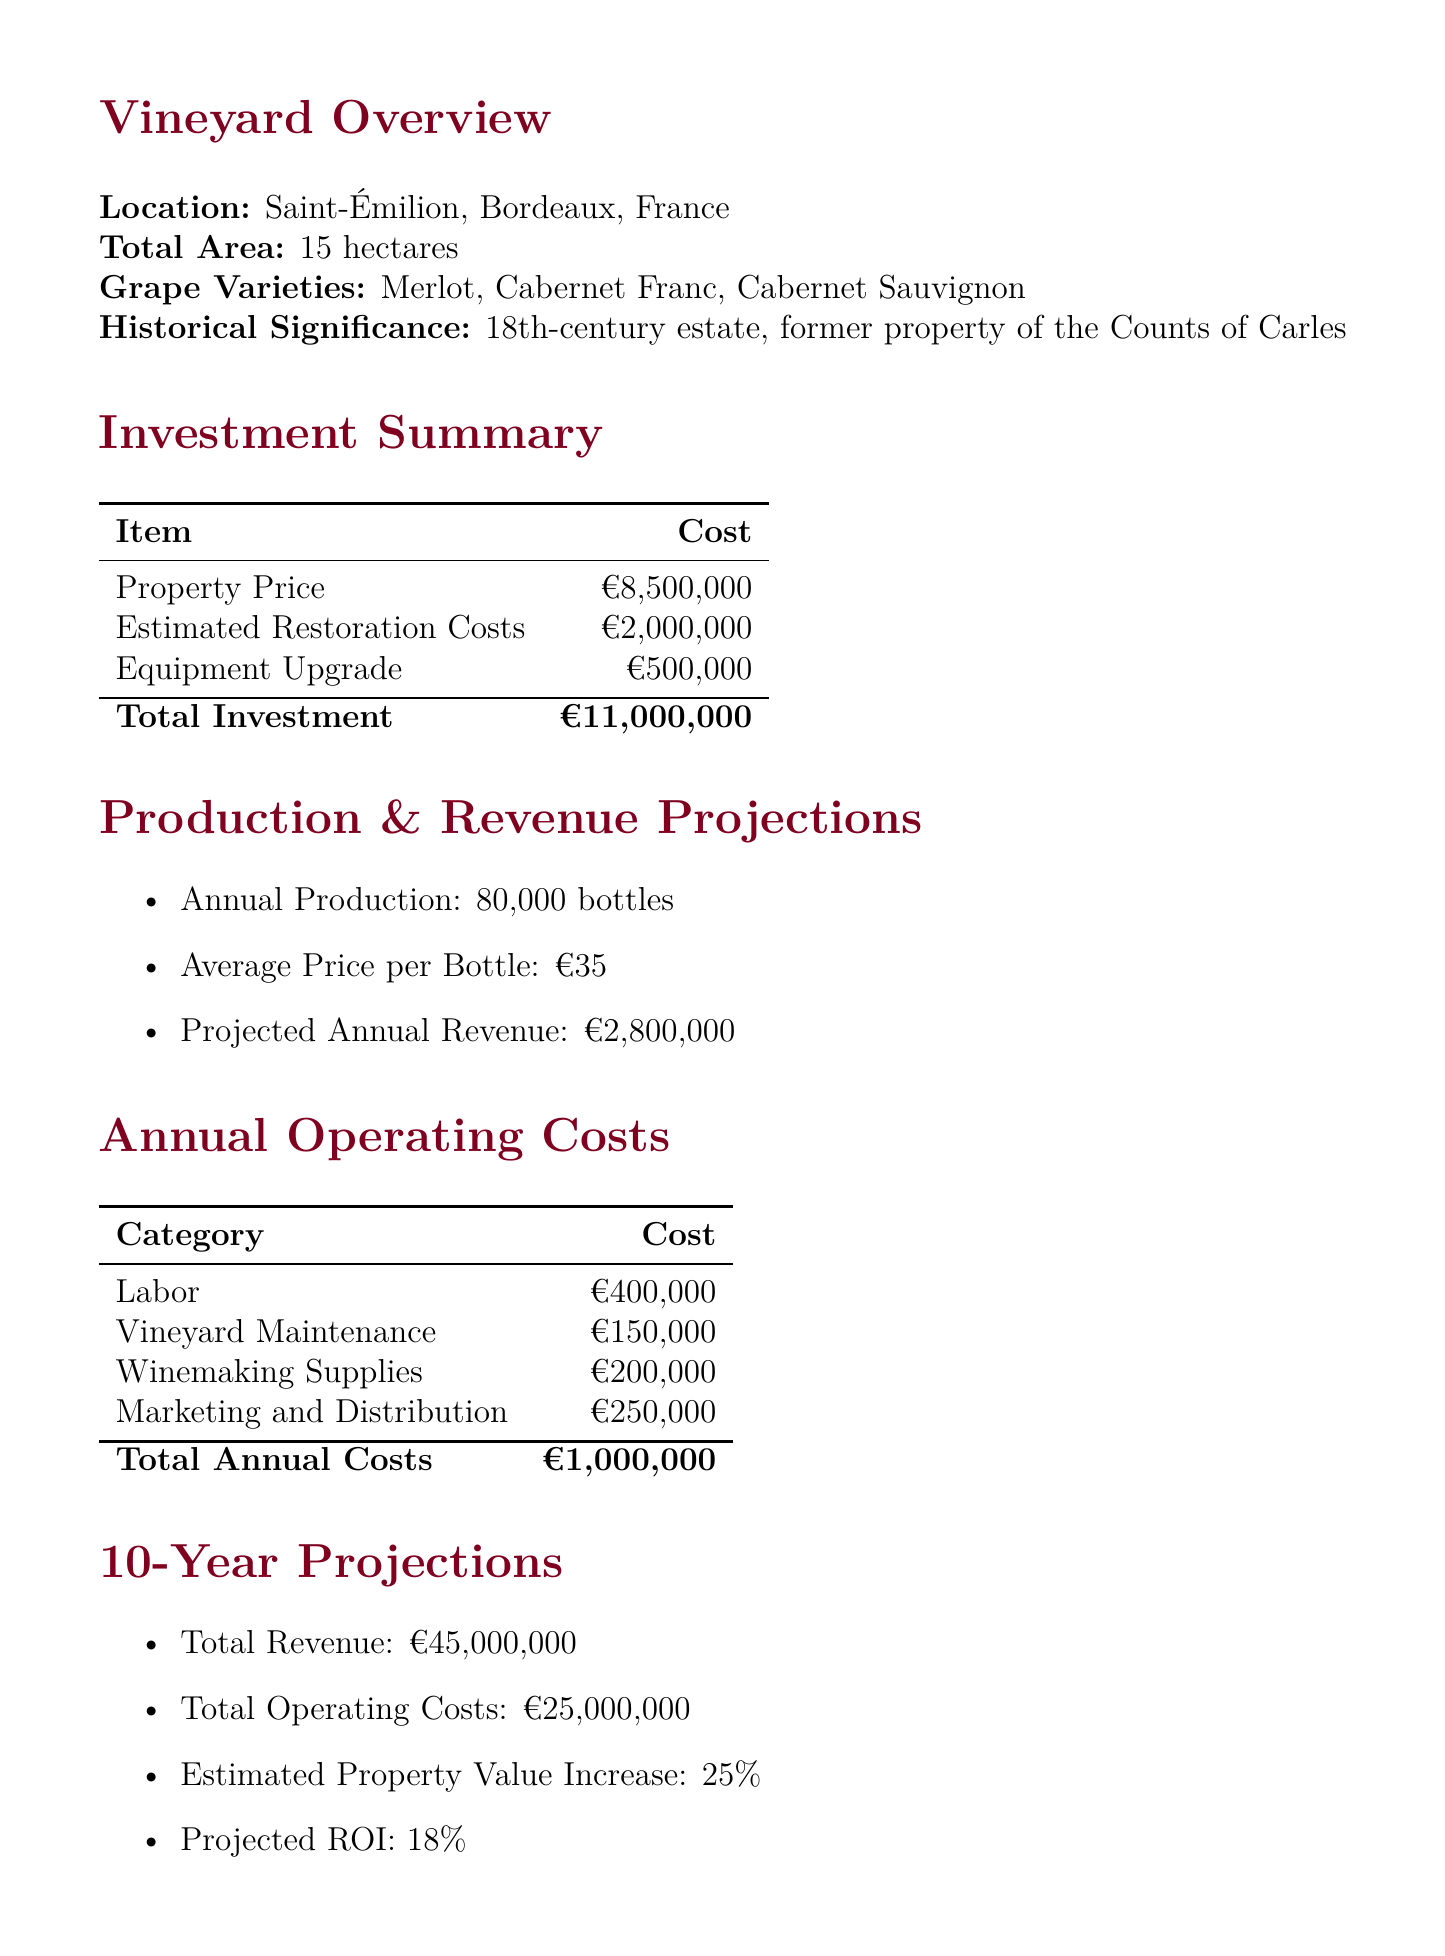What is the location of the vineyard? The document specifies the vineyard's location as Saint-Émilion, Bordeaux, France.
Answer: Saint-Émilion, Bordeaux, France What is the purchase price of the property? The purchase price of the property is explicitly listed in the investment summary.
Answer: €8,500,000 How many hectares is Château Bellevue? The total area of the vineyard is provided in the vineyard overview section.
Answer: 15 hectares What is the average price per bottle of wine? The document presents the average price per bottle in the production & revenue projections section.
Answer: €35 What is the total estimated restoration cost? The total estimated restoration cost is specified in the investment summary.
Answer: €2,000,000 What is the projected ROI over 10 years? The projected ROI is found in the 10-year projections section.
Answer: 18% What are two revenue streams mentioned? The document lists revenue streams in the revenue streams section; any two can be chosen.
Answer: Wine sales, Tourism What is one risk factor related to climate? The risk factors section includes climate change impacts on grape production as one of the risks.
Answer: Climate change impacts on grape production What is the estimated property value increase over 10 years? The projected increase in property value is mentioned in the 10-year projections section.
Answer: 25% 